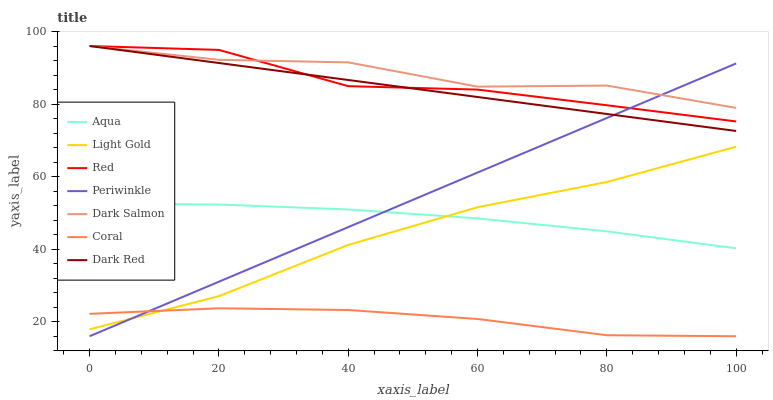Does Coral have the minimum area under the curve?
Answer yes or no. Yes. Does Dark Salmon have the maximum area under the curve?
Answer yes or no. Yes. Does Aqua have the minimum area under the curve?
Answer yes or no. No. Does Aqua have the maximum area under the curve?
Answer yes or no. No. Is Dark Red the smoothest?
Answer yes or no. Yes. Is Dark Salmon the roughest?
Answer yes or no. Yes. Is Coral the smoothest?
Answer yes or no. No. Is Coral the roughest?
Answer yes or no. No. Does Coral have the lowest value?
Answer yes or no. Yes. Does Aqua have the lowest value?
Answer yes or no. No. Does Red have the highest value?
Answer yes or no. Yes. Does Aqua have the highest value?
Answer yes or no. No. Is Light Gold less than Dark Red?
Answer yes or no. Yes. Is Dark Salmon greater than Aqua?
Answer yes or no. Yes. Does Dark Salmon intersect Red?
Answer yes or no. Yes. Is Dark Salmon less than Red?
Answer yes or no. No. Is Dark Salmon greater than Red?
Answer yes or no. No. Does Light Gold intersect Dark Red?
Answer yes or no. No. 